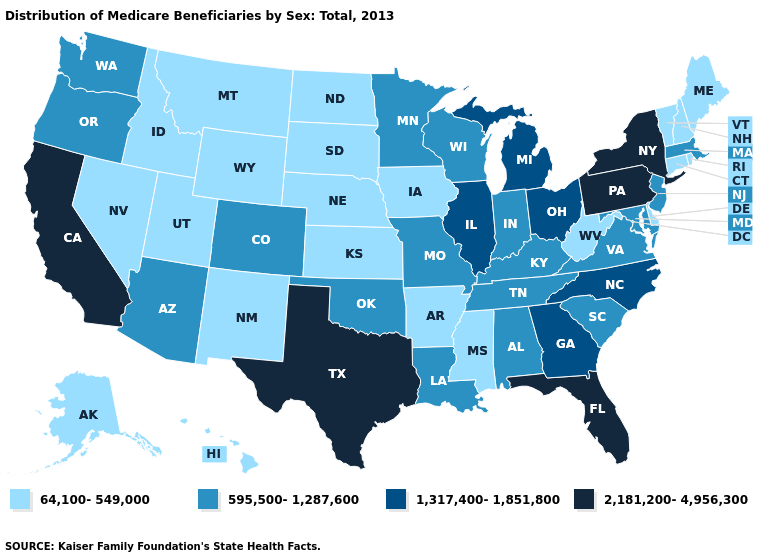What is the value of Oklahoma?
Write a very short answer. 595,500-1,287,600. What is the value of Arizona?
Quick response, please. 595,500-1,287,600. Name the states that have a value in the range 595,500-1,287,600?
Quick response, please. Alabama, Arizona, Colorado, Indiana, Kentucky, Louisiana, Maryland, Massachusetts, Minnesota, Missouri, New Jersey, Oklahoma, Oregon, South Carolina, Tennessee, Virginia, Washington, Wisconsin. Name the states that have a value in the range 595,500-1,287,600?
Be succinct. Alabama, Arizona, Colorado, Indiana, Kentucky, Louisiana, Maryland, Massachusetts, Minnesota, Missouri, New Jersey, Oklahoma, Oregon, South Carolina, Tennessee, Virginia, Washington, Wisconsin. Does the first symbol in the legend represent the smallest category?
Write a very short answer. Yes. Name the states that have a value in the range 595,500-1,287,600?
Quick response, please. Alabama, Arizona, Colorado, Indiana, Kentucky, Louisiana, Maryland, Massachusetts, Minnesota, Missouri, New Jersey, Oklahoma, Oregon, South Carolina, Tennessee, Virginia, Washington, Wisconsin. Among the states that border Nevada , does California have the highest value?
Concise answer only. Yes. Which states have the highest value in the USA?
Keep it brief. California, Florida, New York, Pennsylvania, Texas. What is the value of Colorado?
Give a very brief answer. 595,500-1,287,600. Name the states that have a value in the range 2,181,200-4,956,300?
Be succinct. California, Florida, New York, Pennsylvania, Texas. Does Washington have a higher value than Tennessee?
Give a very brief answer. No. Does Massachusetts have the same value as Missouri?
Short answer required. Yes. What is the lowest value in states that border New Jersey?
Be succinct. 64,100-549,000. What is the value of Ohio?
Keep it brief. 1,317,400-1,851,800. Name the states that have a value in the range 1,317,400-1,851,800?
Short answer required. Georgia, Illinois, Michigan, North Carolina, Ohio. 